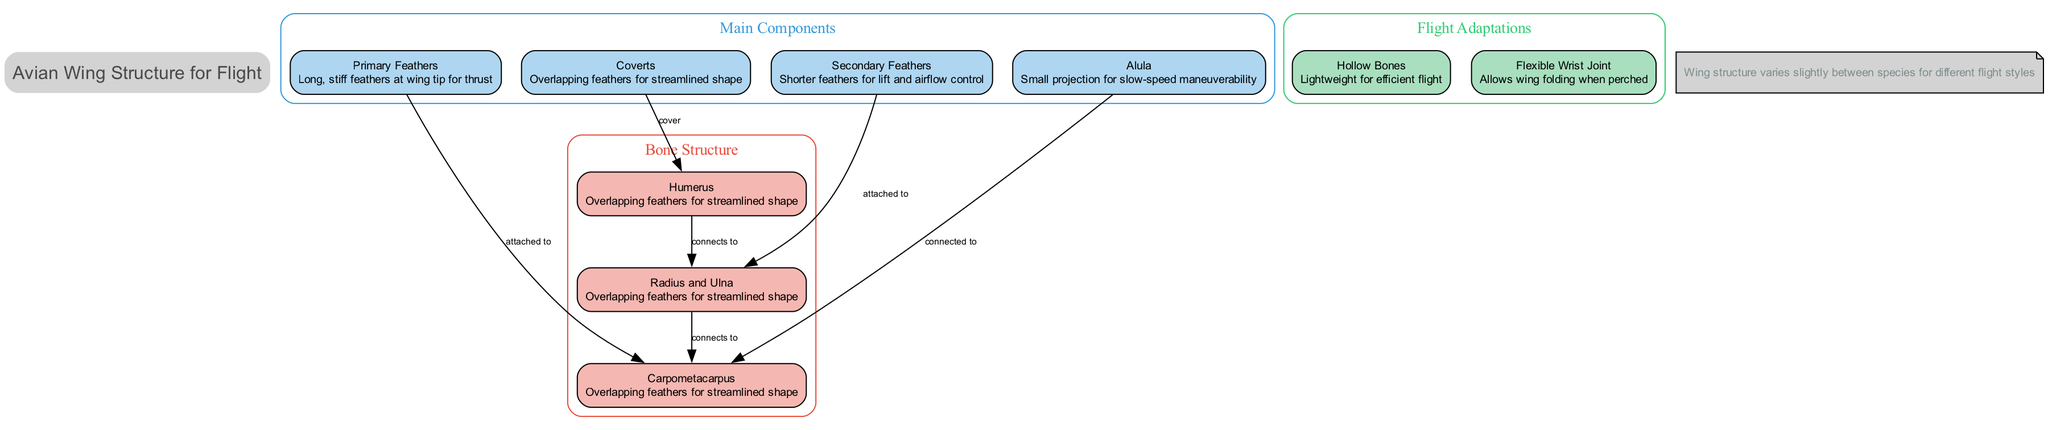What are the primary feathers responsible for? The primary feathers are described as "Long, stiff feathers at wing tip for thrust," indicating their role in providing propulsion to the bird during flight.
Answer: Thrust How many types of feathers are in the main components? The diagram lists four main types of feathers: Primary Feathers, Secondary Feathers, Alula, and Coverts. Thus, there are four different types.
Answer: Four What connects to the Secondary Feathers? The diagram shows an arrow labeled "attached to" pointing from Secondary Feathers to Radius and Ulna, indicating that they are physically connected to these bones.
Answer: Radius and Ulna Which adaptation allows the wing to fold when perched? The flight adaptation noted as "Flexible Wrist Joint" is specifically mentioned for its function in allowing the wing to fold, indicating its importance in the resting position of birds.
Answer: Flexible Wrist Joint What is the description of the Humerus? The Humerus is categorized under bone structure and is described as the "Upper arm bone," providing basic identification of this component in the avian wing.
Answer: Upper arm bone How does the Alula assist in flight? The Alula is described as allowing for "slow-speed maneuverability," indicating its role in enhancing control while flying, especially at lower speeds.
Answer: Slow-speed maneuverability What type of bones are described as lightweight for efficient flight? Hollow Bones are referred to in the flight adaptations and characterized as "Lightweight for efficient flight," indicating their crucial role in making the bird lighter for flight.
Answer: Hollow Bones How are Coverts positioned in relation to the Humerus? The diagram denotes an edge indicating that Coverts "cover" the Humerus, which implies that they overlap and provide streamlined support.
Answer: Cover What is the overall note about wing structure? The note at the bottom of the diagram states, "Wing structure varies slightly between species for different flight styles," indicating the diversity and adaptability in avian anatomy based on species.
Answer: Varied structure across species 